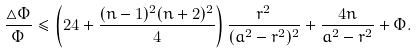Convert formula to latex. <formula><loc_0><loc_0><loc_500><loc_500>\frac { \triangle \Phi } { \Phi } \leq \left ( 2 4 + \frac { ( n - 1 ) ^ { 2 } ( n + 2 ) ^ { 2 } } { 4 } \right ) \frac { r ^ { 2 } } { ( a ^ { 2 } - r ^ { 2 } ) ^ { 2 } } + \frac { 4 n } { a ^ { 2 } - r ^ { 2 } } + \Phi .</formula> 